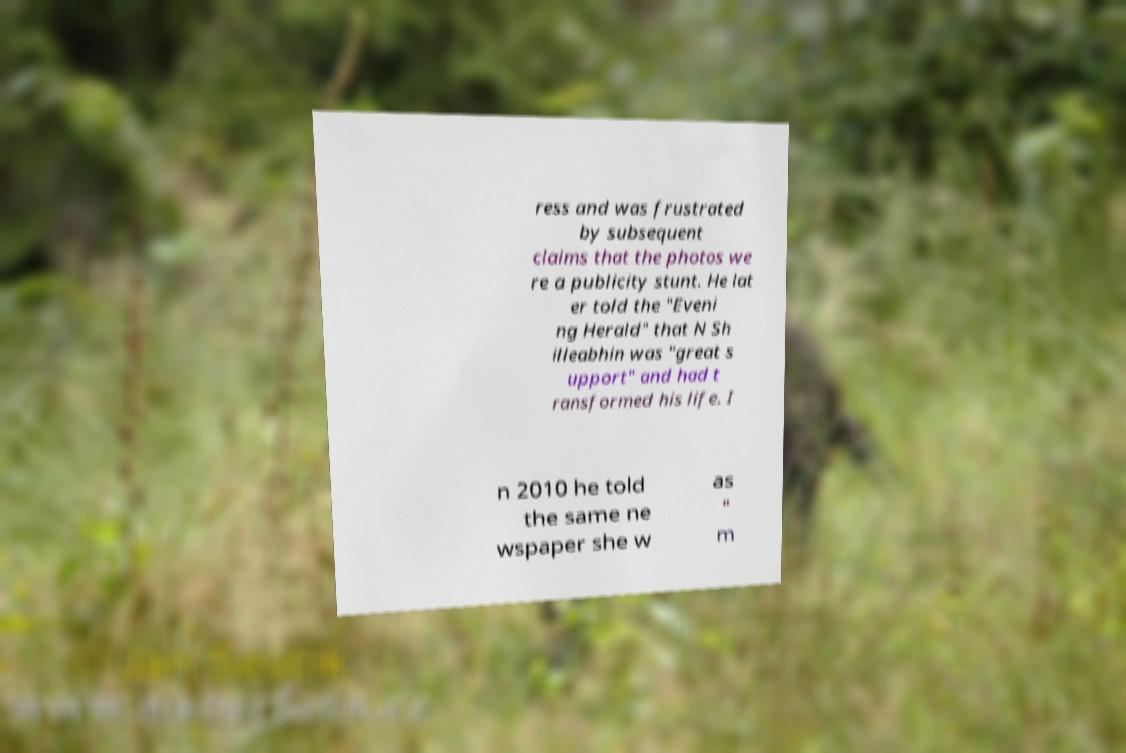Please read and relay the text visible in this image. What does it say? ress and was frustrated by subsequent claims that the photos we re a publicity stunt. He lat er told the "Eveni ng Herald" that N Sh illeabhin was "great s upport" and had t ransformed his life. I n 2010 he told the same ne wspaper she w as " m 